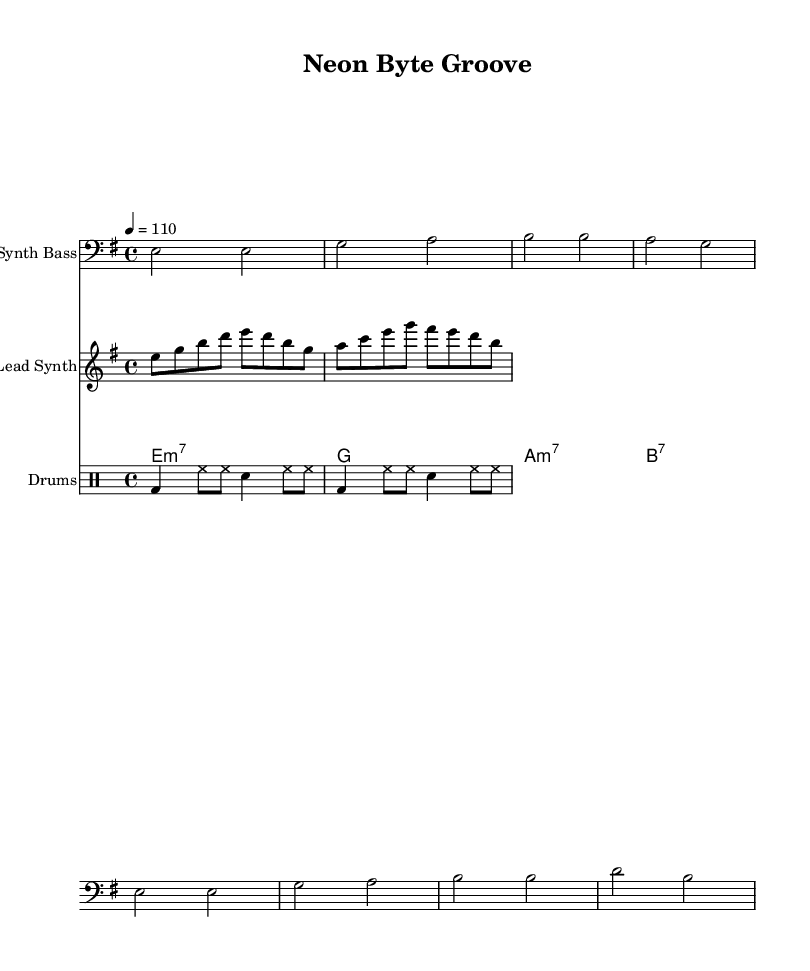What is the key signature of this music? The key signature shown in the music indicates E minor, which has one sharp (F#). This is determined by looking at the key signature at the beginning of the staff where it shows the F# sharp on the staff lines.
Answer: E minor What is the time signature of this music? The time signature is found in the beginning of the score. It is displayed as 4/4, meaning there are four beats in each measure and the quarter note gets the beat.
Answer: 4/4 What is the tempo marking for this piece? The tempo marking is indicated by the number next to the tempo command; in this case, it specifies a tempo of 110 beats per minute. This suggests a medium dance pace typical of funk music.
Answer: 110 How many measures does the Lead Synth part contain? By counting the measures in the provided music notation for the Lead Synth, there are a total of 8 measures presented in the score.
Answer: 8 What chord is used in the third measure of the Rhythm Guitar? The third measure of the Rhythm Guitar section shows an A minor 7 chord, indicated by the chord symbol "a1:m7". This specifies the type of chord played in that measure.
Answer: A minor 7 Which percussion instrument is indicated by the first part of the drum patterns? The first part of the drum patterns shows a bass drum, indicated by "bd" in the drum notation. This signifies the use of the bass drum in creating the rhythm.
Answer: Bass drum What type of musical harmony is primarily utilized in the Synth Bass? The Synth Bass is based largely on the minor scale harmonies, specifically using E minor for its chords, which implies a mood suited for funk music.
Answer: Minor harmony 